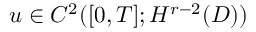Convert formula to latex. <formula><loc_0><loc_0><loc_500><loc_500>u \in C ^ { 2 } ( [ 0 , T ] ; H ^ { r - 2 } ( D ) )</formula> 